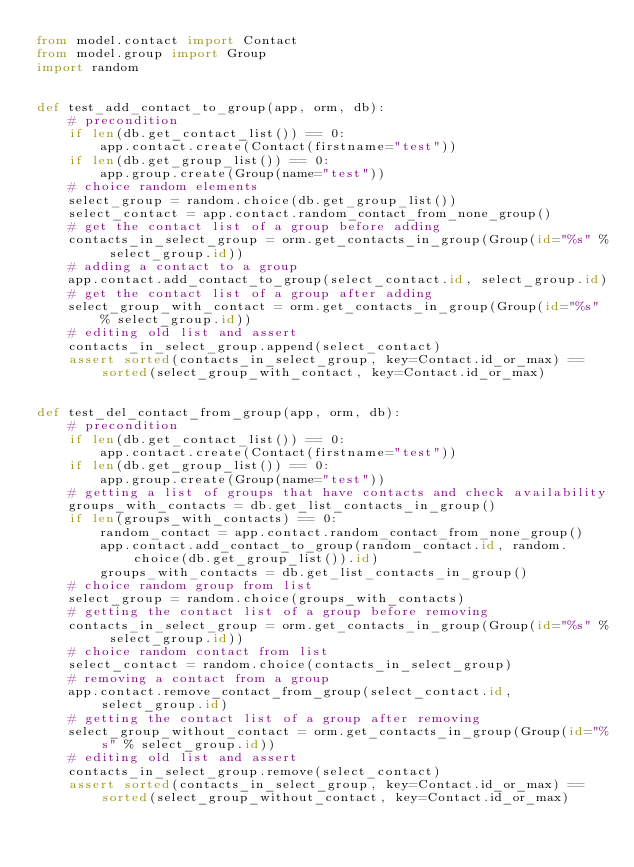<code> <loc_0><loc_0><loc_500><loc_500><_Python_>from model.contact import Contact
from model.group import Group
import random


def test_add_contact_to_group(app, orm, db):
    # precondition
    if len(db.get_contact_list()) == 0:
        app.contact.create(Contact(firstname="test"))
    if len(db.get_group_list()) == 0:
        app.group.create(Group(name="test"))
    # choice random elements
    select_group = random.choice(db.get_group_list())
    select_contact = app.contact.random_contact_from_none_group()
    # get the contact list of a group before adding
    contacts_in_select_group = orm.get_contacts_in_group(Group(id="%s" % select_group.id))
    # adding a contact to a group
    app.contact.add_contact_to_group(select_contact.id, select_group.id)
    # get the contact list of a group after adding
    select_group_with_contact = orm.get_contacts_in_group(Group(id="%s" % select_group.id))
    # editing old list and assert
    contacts_in_select_group.append(select_contact)
    assert sorted(contacts_in_select_group, key=Contact.id_or_max) == sorted(select_group_with_contact, key=Contact.id_or_max)


def test_del_contact_from_group(app, orm, db):
    # precondition
    if len(db.get_contact_list()) == 0:
        app.contact.create(Contact(firstname="test"))
    if len(db.get_group_list()) == 0:
        app.group.create(Group(name="test"))
    # getting a list of groups that have contacts and check availability
    groups_with_contacts = db.get_list_contacts_in_group()
    if len(groups_with_contacts) == 0:
        random_contact = app.contact.random_contact_from_none_group()
        app.contact.add_contact_to_group(random_contact.id, random.choice(db.get_group_list()).id)
        groups_with_contacts = db.get_list_contacts_in_group()
    # choice random group from list
    select_group = random.choice(groups_with_contacts)
    # getting the contact list of a group before removing
    contacts_in_select_group = orm.get_contacts_in_group(Group(id="%s" % select_group.id))
    # choice random contact from list
    select_contact = random.choice(contacts_in_select_group)
    # removing a contact from a group
    app.contact.remove_contact_from_group(select_contact.id, select_group.id)
    # getting the contact list of a group after removing
    select_group_without_contact = orm.get_contacts_in_group(Group(id="%s" % select_group.id))
    # editing old list and assert
    contacts_in_select_group.remove(select_contact)
    assert sorted(contacts_in_select_group, key=Contact.id_or_max) == sorted(select_group_without_contact, key=Contact.id_or_max)
</code> 